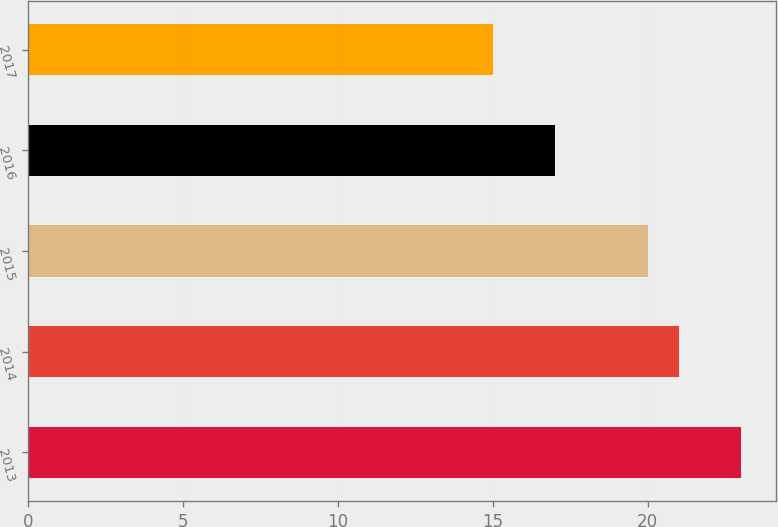<chart> <loc_0><loc_0><loc_500><loc_500><bar_chart><fcel>2013<fcel>2014<fcel>2015<fcel>2016<fcel>2017<nl><fcel>23<fcel>21<fcel>20<fcel>17<fcel>15<nl></chart> 